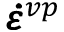Convert formula to latex. <formula><loc_0><loc_0><loc_500><loc_500>\pm b { \dot { \varepsilon } } ^ { v p }</formula> 